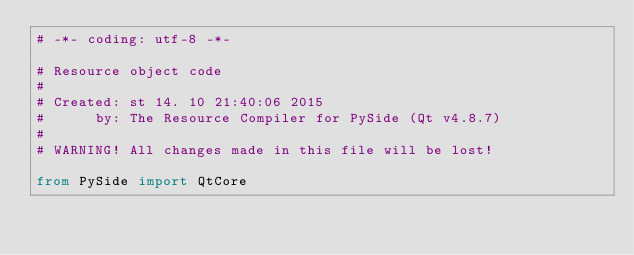Convert code to text. <code><loc_0><loc_0><loc_500><loc_500><_Python_># -*- coding: utf-8 -*-

# Resource object code
#
# Created: st 14. 10 21:40:06 2015
#      by: The Resource Compiler for PySide (Qt v4.8.7)
#
# WARNING! All changes made in this file will be lost!

from PySide import QtCore
</code> 